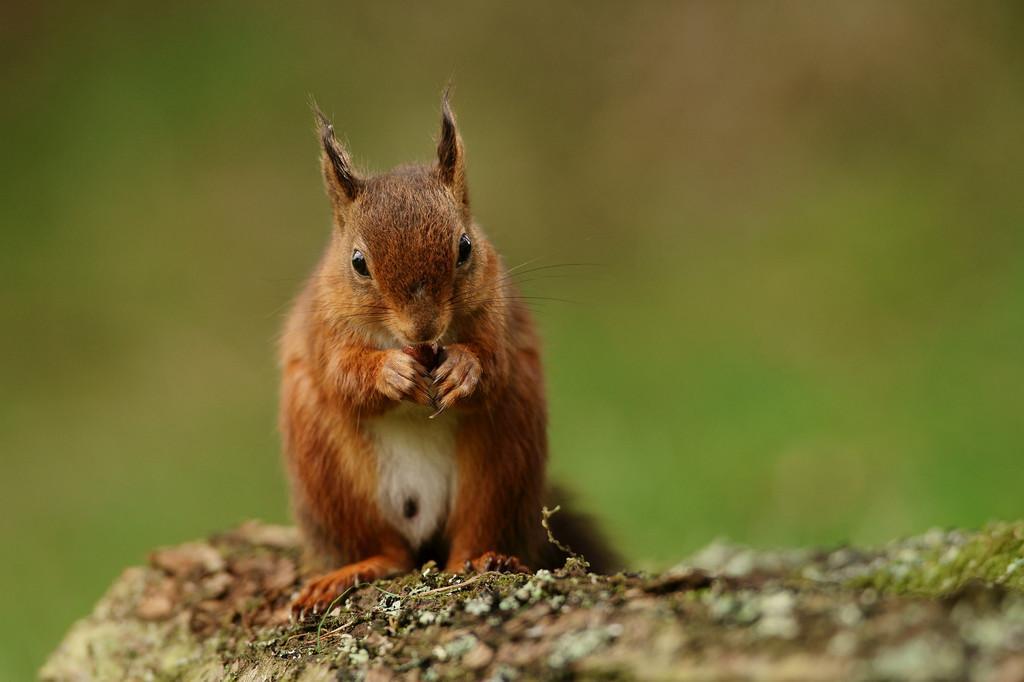In one or two sentences, can you explain what this image depicts? In the image there is a brown squirrel holding a nut, standing on a rock and the background is blurry. 